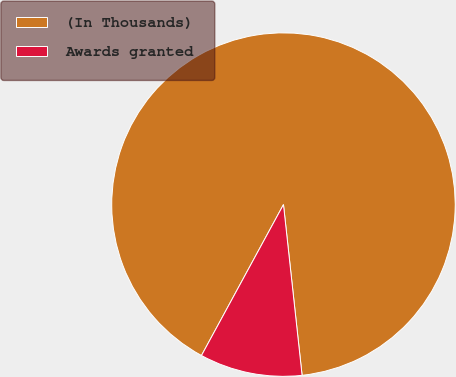Convert chart. <chart><loc_0><loc_0><loc_500><loc_500><pie_chart><fcel>(In Thousands)<fcel>Awards granted<nl><fcel>90.35%<fcel>9.65%<nl></chart> 